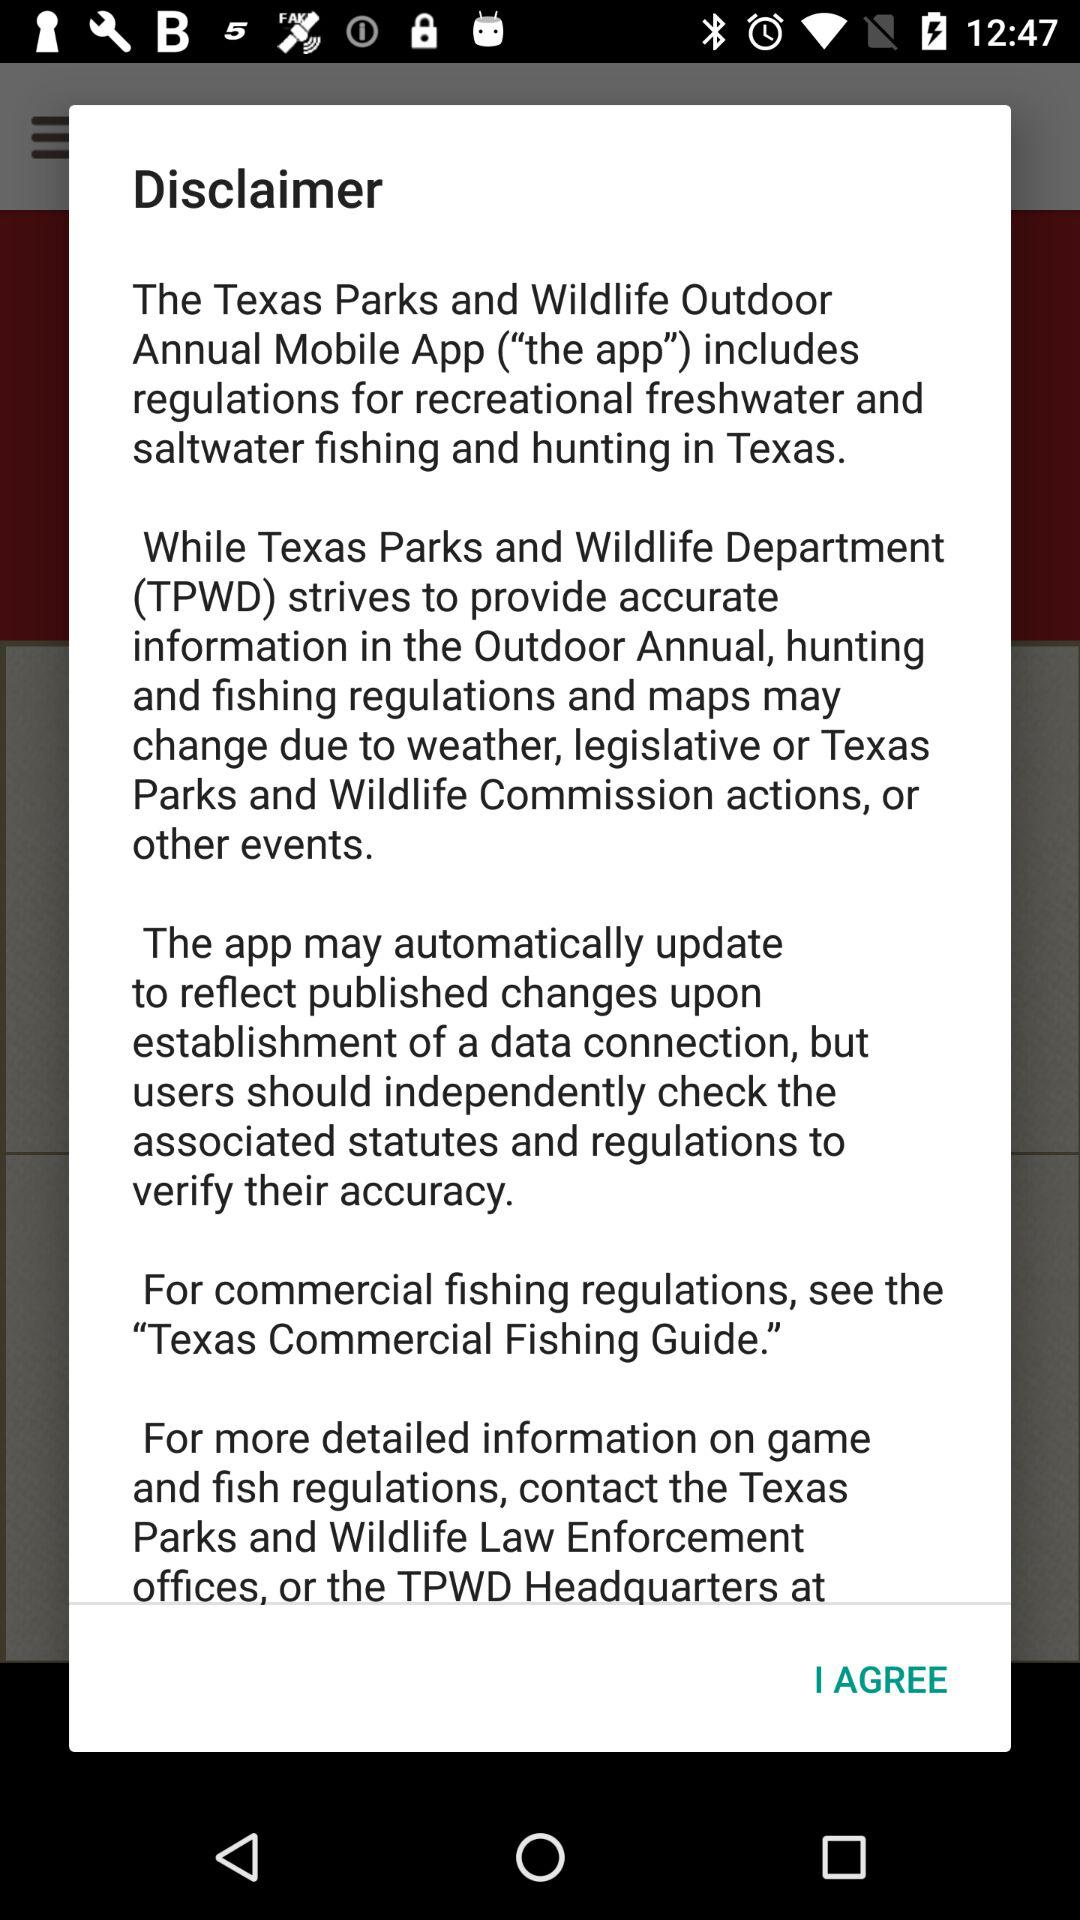How many sentences are there in the disclaimer?
Answer the question using a single word or phrase. 4 